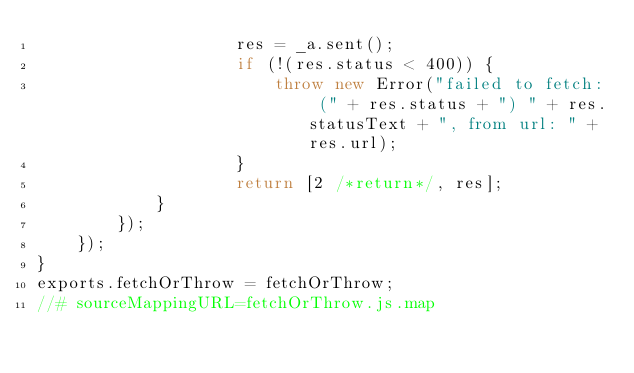Convert code to text. <code><loc_0><loc_0><loc_500><loc_500><_JavaScript_>                    res = _a.sent();
                    if (!(res.status < 400)) {
                        throw new Error("failed to fetch: (" + res.status + ") " + res.statusText + ", from url: " + res.url);
                    }
                    return [2 /*return*/, res];
            }
        });
    });
}
exports.fetchOrThrow = fetchOrThrow;
//# sourceMappingURL=fetchOrThrow.js.map</code> 